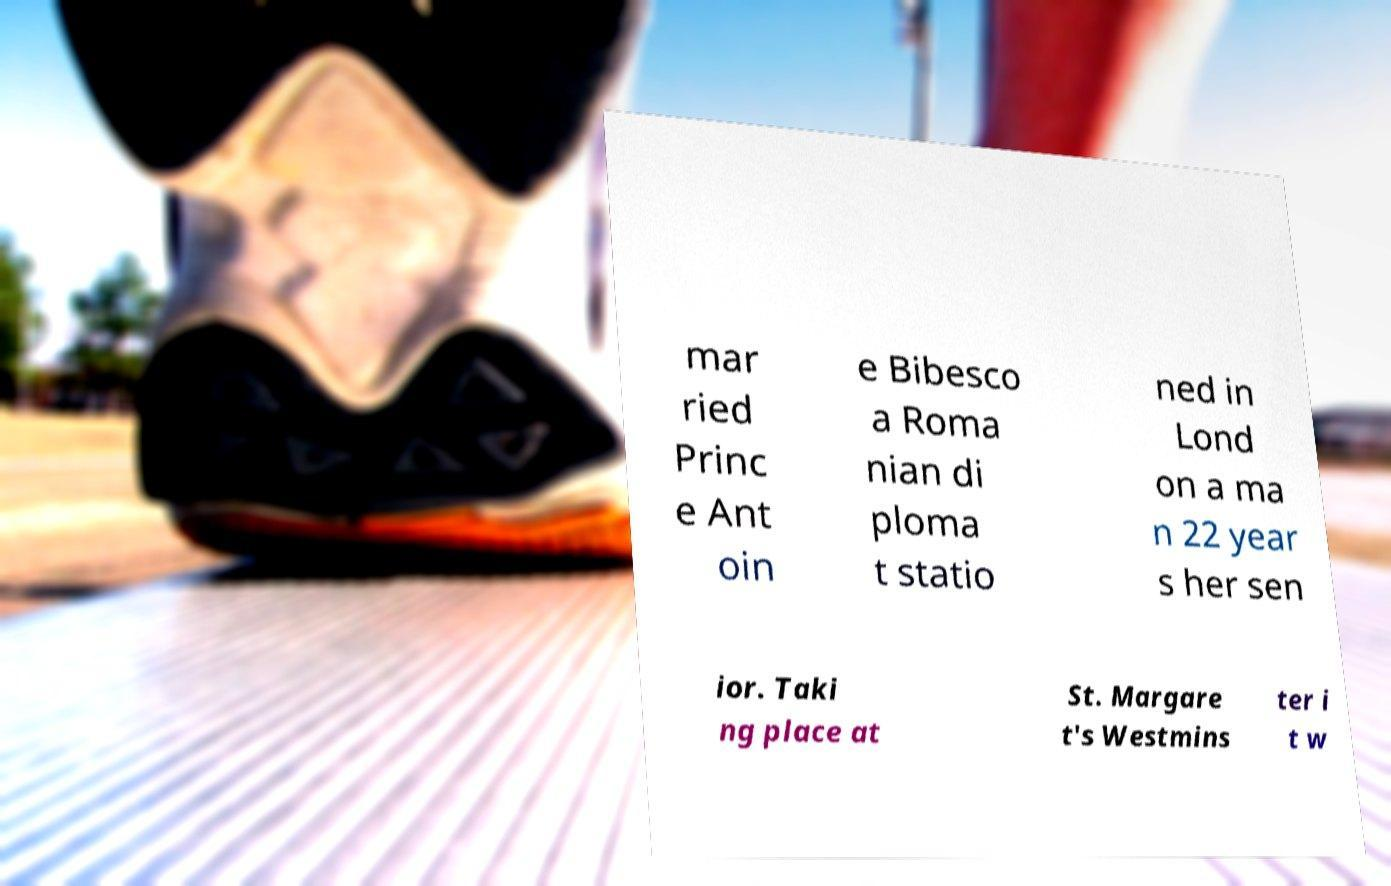I need the written content from this picture converted into text. Can you do that? mar ried Princ e Ant oin e Bibesco a Roma nian di ploma t statio ned in Lond on a ma n 22 year s her sen ior. Taki ng place at St. Margare t's Westmins ter i t w 